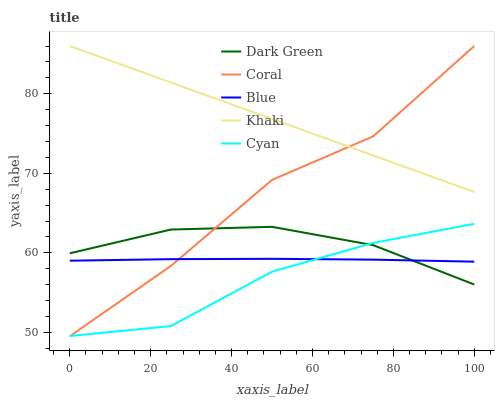Does Cyan have the minimum area under the curve?
Answer yes or no. Yes. Does Khaki have the maximum area under the curve?
Answer yes or no. Yes. Does Coral have the minimum area under the curve?
Answer yes or no. No. Does Coral have the maximum area under the curve?
Answer yes or no. No. Is Khaki the smoothest?
Answer yes or no. Yes. Is Coral the roughest?
Answer yes or no. Yes. Is Cyan the smoothest?
Answer yes or no. No. Is Cyan the roughest?
Answer yes or no. No. Does Coral have the lowest value?
Answer yes or no. Yes. Does Cyan have the lowest value?
Answer yes or no. No. Does Khaki have the highest value?
Answer yes or no. Yes. Does Cyan have the highest value?
Answer yes or no. No. Is Cyan less than Khaki?
Answer yes or no. Yes. Is Khaki greater than Cyan?
Answer yes or no. Yes. Does Blue intersect Cyan?
Answer yes or no. Yes. Is Blue less than Cyan?
Answer yes or no. No. Is Blue greater than Cyan?
Answer yes or no. No. Does Cyan intersect Khaki?
Answer yes or no. No. 